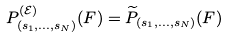<formula> <loc_0><loc_0><loc_500><loc_500>P _ { ( s _ { 1 } , \dots , s _ { N } ) } ^ { ( \mathcal { E } ) } ( F ) = \widetilde { P } _ { ( s _ { 1 } , \dots , s _ { N } ) } ( F )</formula> 